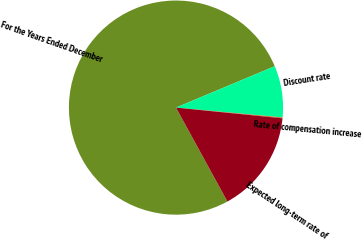Convert chart to OTSL. <chart><loc_0><loc_0><loc_500><loc_500><pie_chart><fcel>For the Years Ended December<fcel>Discount rate<fcel>Rate of compensation increase<fcel>Expected long-term rate of<nl><fcel>76.66%<fcel>7.78%<fcel>0.13%<fcel>15.43%<nl></chart> 